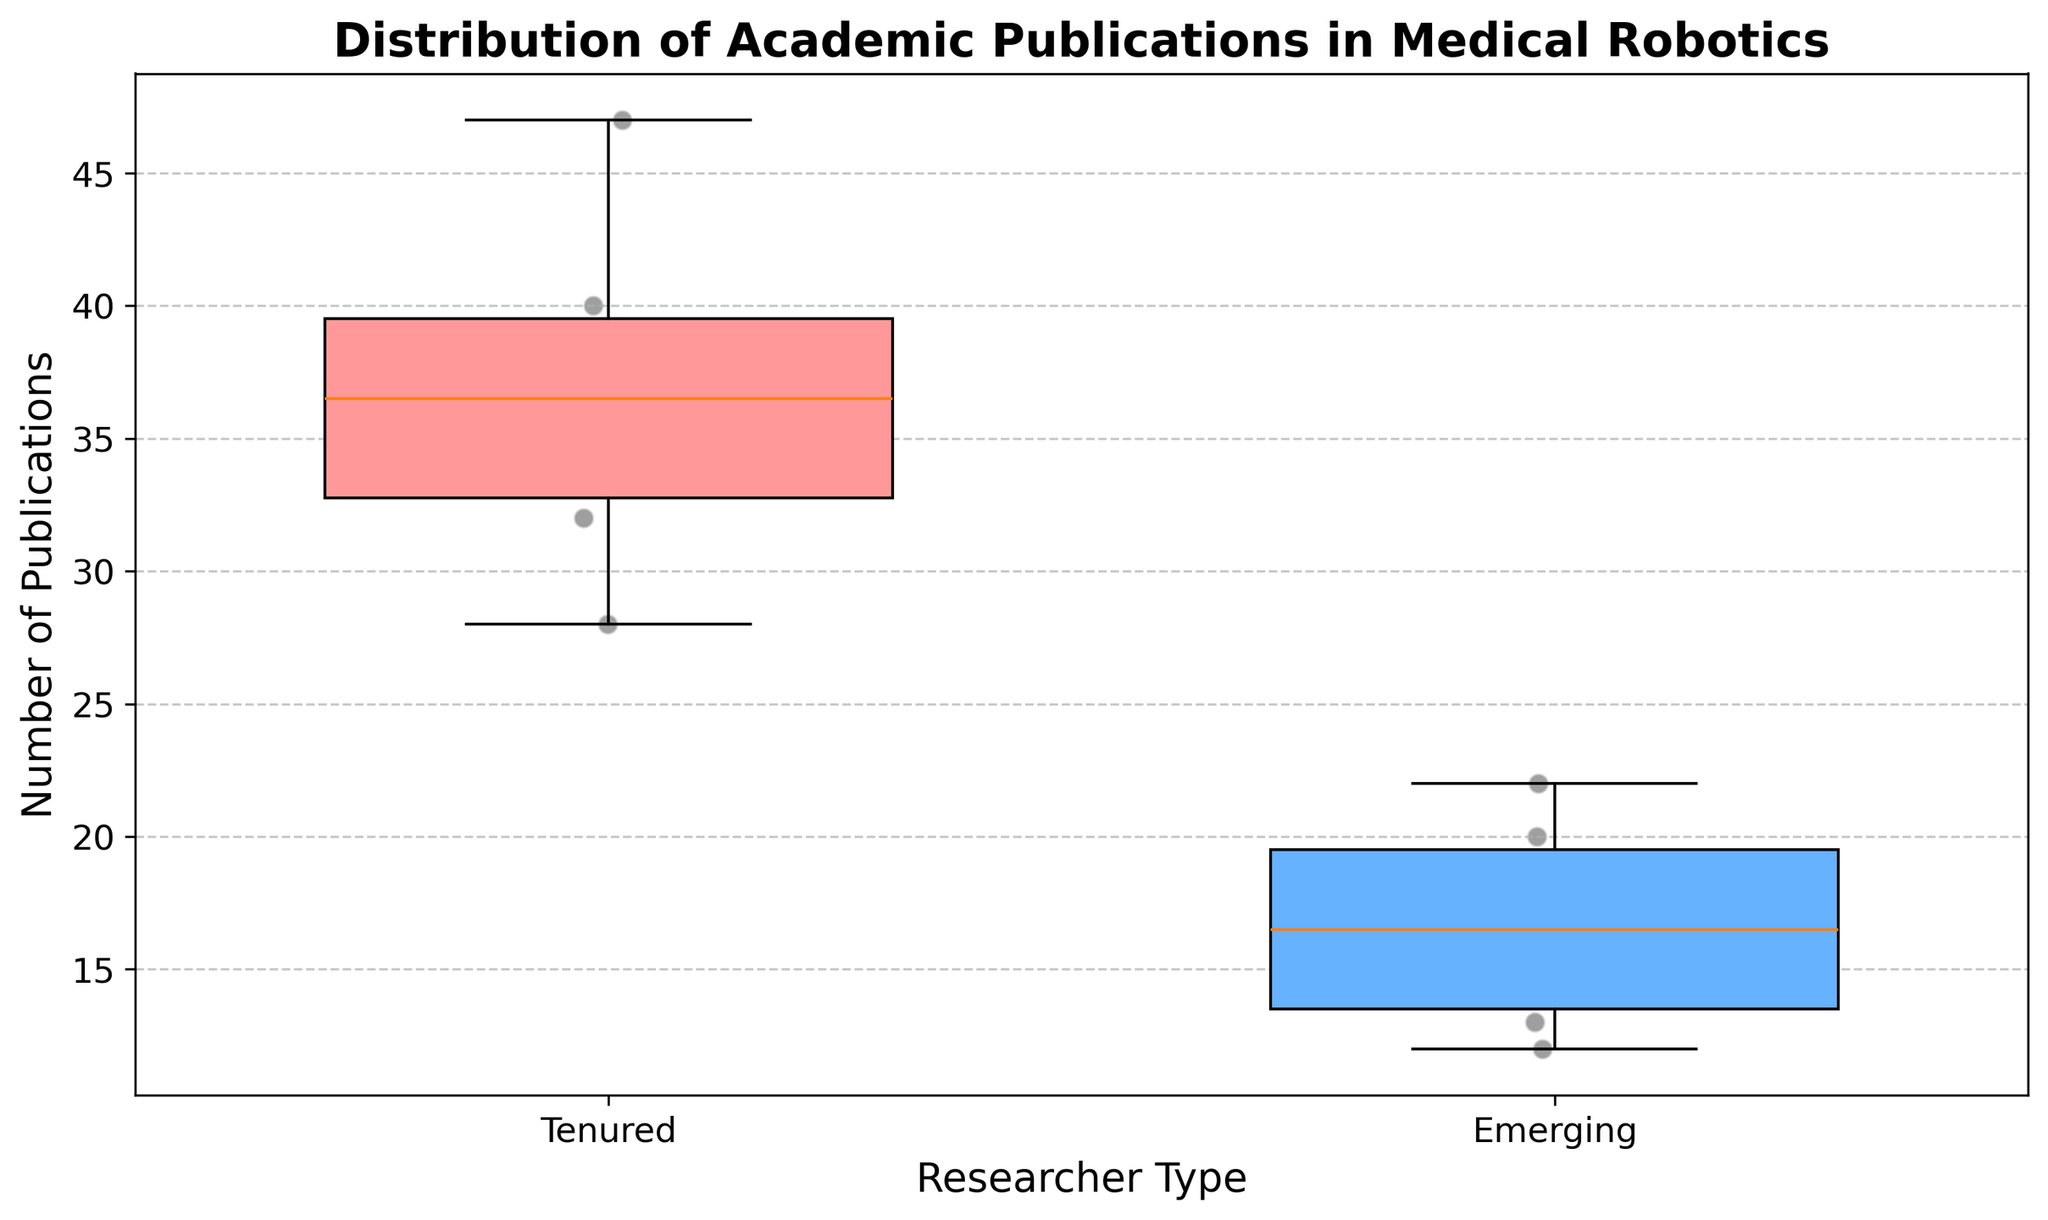What is the title of the figure? The title of the figure is displayed at the top and reads: "Distribution of Academic Publications in Medical Robotics".
Answer: Distribution of Academic Publications in Medical Robotics Which researcher type is represented by the color red? The Tenured researchers are represented by the red color in the box plot. This can be identified by looking at the color filling of the Tenured group's box.
Answer: Tenured How many individual data points are there for Emerging researchers? By counting the scatter points over the blue box (representing Emerging researchers), we can see there are 6 data points.
Answer: 6 What is the median number of publications for Tenured researchers? The median is represented by the line inside the Tenured box. By observing the figure, the median number of publications for Tenured researchers is around 35.
Answer: 35 Which group shows a higher variability in publication count? Variability is indicated by the interquartile range (IQR) shown by the height of the boxes. The Tenured group's box is taller, indicating higher variability.
Answer: Tenured What's the range of publication counts for Emerging researchers? The range is the difference between the highest and lowest points in the box plot. For Emerging researchers, the highest point is 22 and the lowest is 12. So, the range is 22 - 12.
Answer: 10 Which researcher has the highest number of publications? By looking at the scatter points, Prof. Russell H. Taylor has the highest number of publications at 47.
Answer: Prof. Russell H. Taylor Compare the median publication counts between Tenured and Emerging researchers. The median for Tenured researchers is around 35, whereas the median for Emerging researchers is around 17. This shows that Tenured researchers have a higher median publication count compared to Emerging researchers.
Answer: Tenured researchers have a higher median What is the interquartile range (IQR) for Tenured researchers? The IQR is the difference between the third quartile (upper edge of the box) and the first quartile (lower edge of the box) in the box plot. For Tenured researchers, it is approximately 40 - 30.
Answer: 10 What can be inferred about the total number of publications between the groups? By comparing the plot widths and heights, Tenured researchers show a wider range and a higher central tendency, indicating a generally higher total number of publications.
Answer: Tenured researchers have more publications overall 